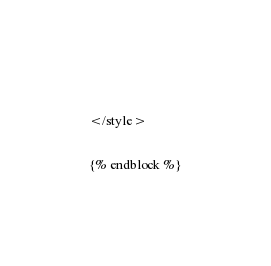Convert code to text. <code><loc_0><loc_0><loc_500><loc_500><_HTML_> 
</style>

{% endblock %}</code> 